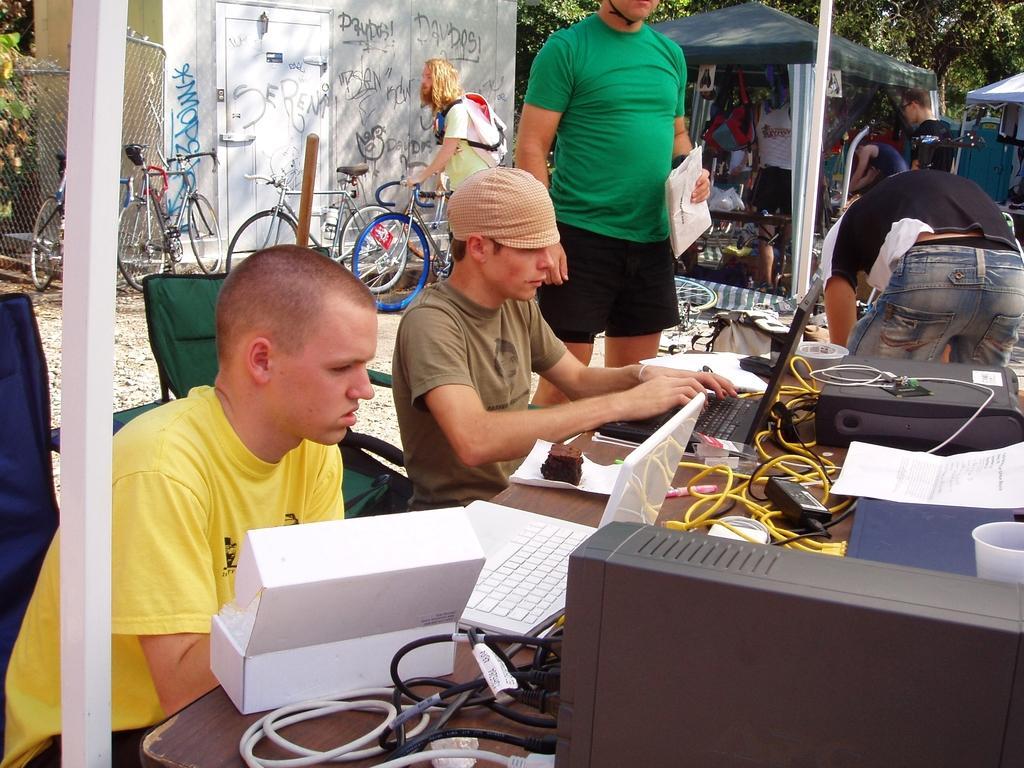Please provide a concise description of this image. This picture shows a couple of Men seated on the chairs and working on the laptops and we see papers and a box on the table and we see a man standing and holding papers in his hand and we see few of them standing on the side and few bicycles parked and we see another man holding bicycle and he wore a backpack on his back and we see trees and couple of tents. 